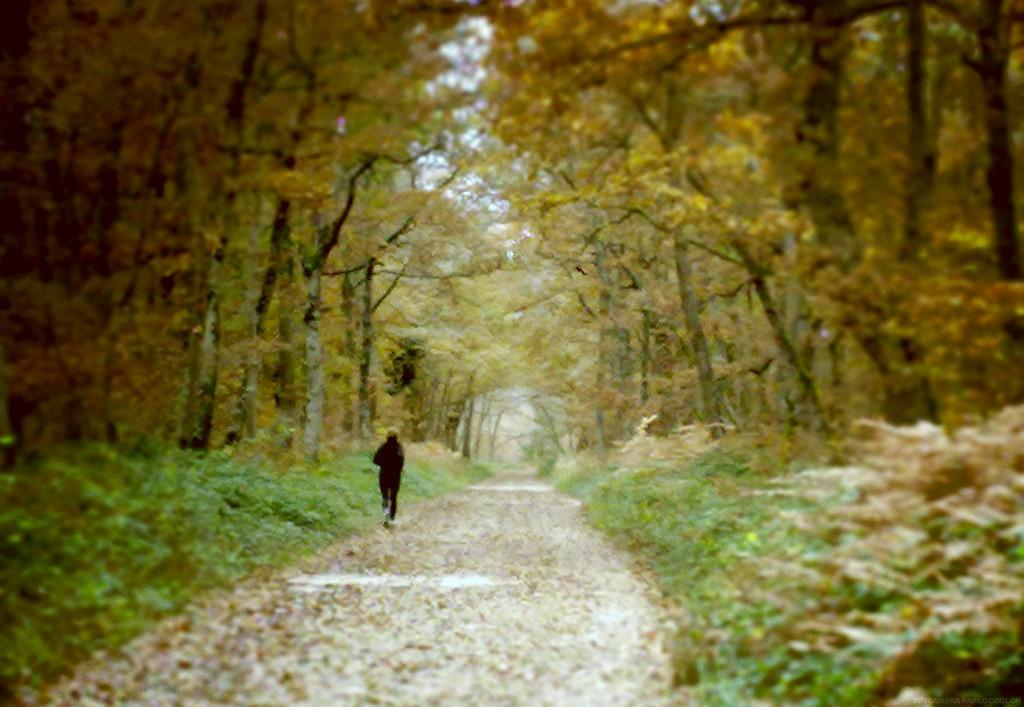What is the person in the image doing? The person is running in the image. What surface is the person running on? The person is running on the ground. What type of vegetation can be seen in the image? There are many trees in the image. What is the ground made of in the image? The ground is covered with grass, which is visible in the image. How many fingers does the person have on their left hand in the image? The image does not show the person's fingers or hands, so it cannot be determined how many fingers they have on their left hand. 